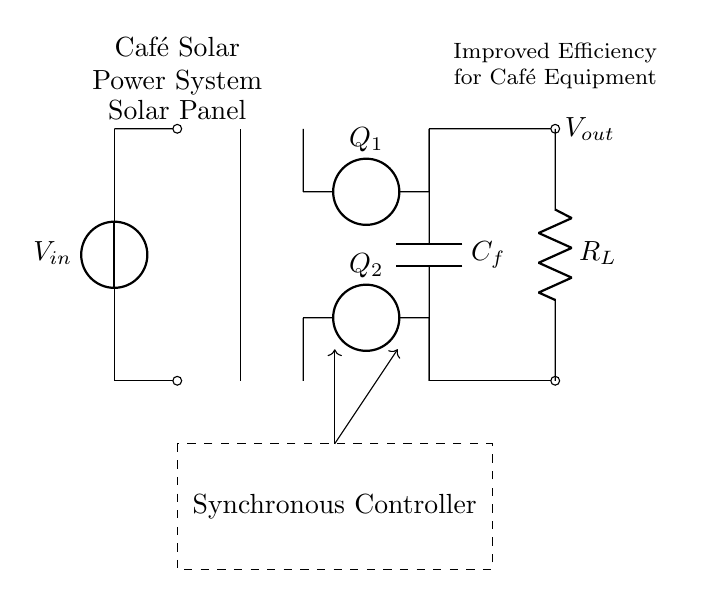What is the input voltage of the circuit? The input voltage is denoted as V_in on the source provided in the circuit.
Answer: V_in What is the function of the synchronous controller? The synchronous controller compares the output voltage to the reference and controls the switching of the transistors to improve efficiency in rectifying the current.
Answer: Improve efficiency What are the components used to rectify the voltage in this circuit? The components used for rectification in this circuit are the two voltage sources labeled Q_1 and Q_2. They function as switches to direct current flow efficiently.
Answer: Q_1 and Q_2 What is the purpose of the output capacitor C_f? The output capacitor C_f smoothens the output voltage by reducing ripple, which is crucial for stable power supply to café equipment.
Answer: Smooth output voltage How is the load connected in this circuit? The load, represented by R_L, is connected in parallel with the output capacitor C_f, allowing it to receive the rectified and smoothed voltage.
Answer: In parallel with C_f What type of rectifier is represented in this circuit? This circuit uses a synchronous rectifier, which employs controlled switches (Q_1 and Q_2) instead of diodes to achieve higher efficiency.
Answer: Synchronous rectifier 